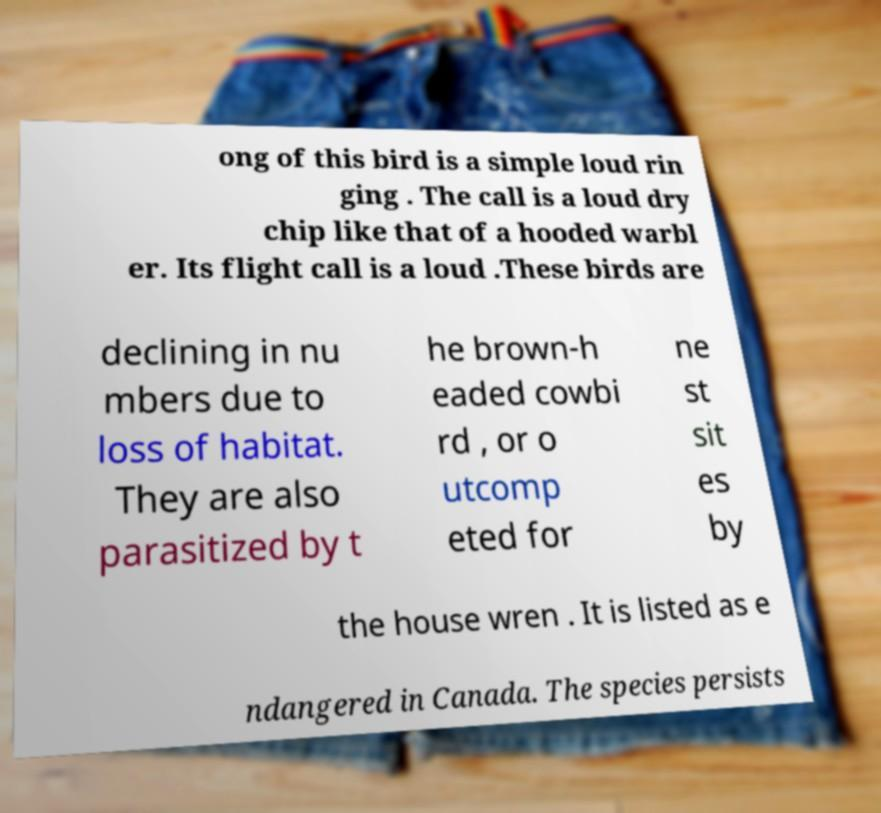Please identify and transcribe the text found in this image. ong of this bird is a simple loud rin ging . The call is a loud dry chip like that of a hooded warbl er. Its flight call is a loud .These birds are declining in nu mbers due to loss of habitat. They are also parasitized by t he brown-h eaded cowbi rd , or o utcomp eted for ne st sit es by the house wren . It is listed as e ndangered in Canada. The species persists 